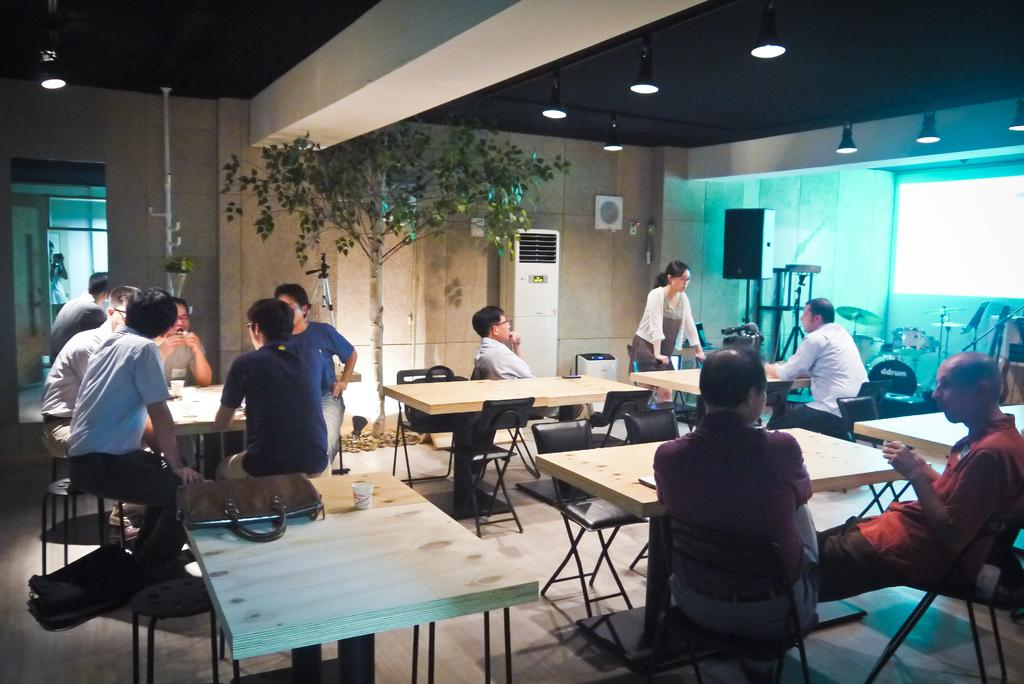What are the people in the image doing? The people in the image are sitting in chairs. What is the woman in the image doing? The woman is standing on the floor in the image. What type of furniture is present in the room? The room contains tables and chairs. What other items can be seen in the room? The room contains bags and cups. What is the color of the background in the image? The background of the image appears to be white. What type of plough is being used in the image? There is no plough present in the image. How many sacks of reward are visible in the image? There are no sacks or rewards present in the image. 